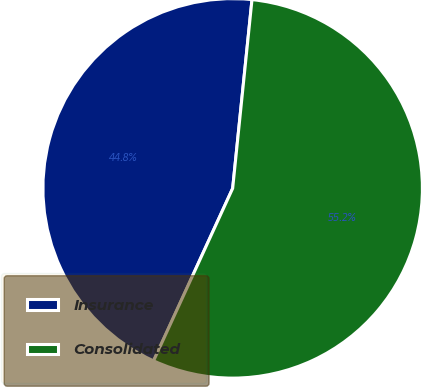Convert chart to OTSL. <chart><loc_0><loc_0><loc_500><loc_500><pie_chart><fcel>Insurance<fcel>Consolidated<nl><fcel>44.78%<fcel>55.22%<nl></chart> 